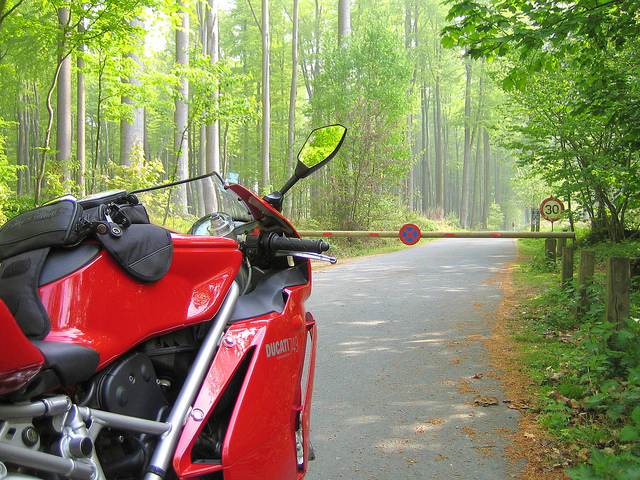Extract all visible text content from this image. DUCATI 30 